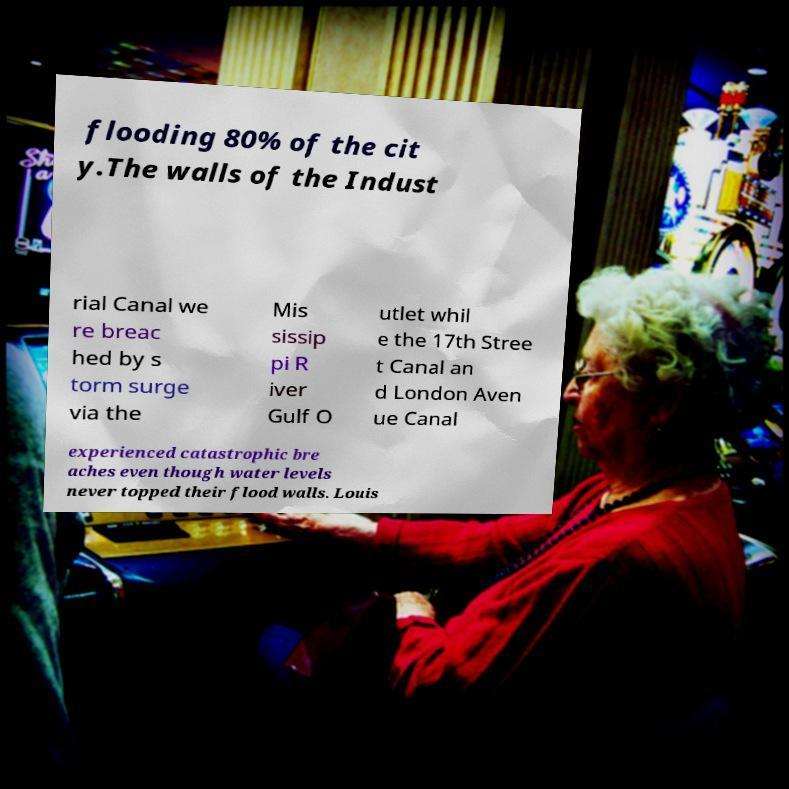Could you assist in decoding the text presented in this image and type it out clearly? flooding 80% of the cit y.The walls of the Indust rial Canal we re breac hed by s torm surge via the Mis sissip pi R iver Gulf O utlet whil e the 17th Stree t Canal an d London Aven ue Canal experienced catastrophic bre aches even though water levels never topped their flood walls. Louis 